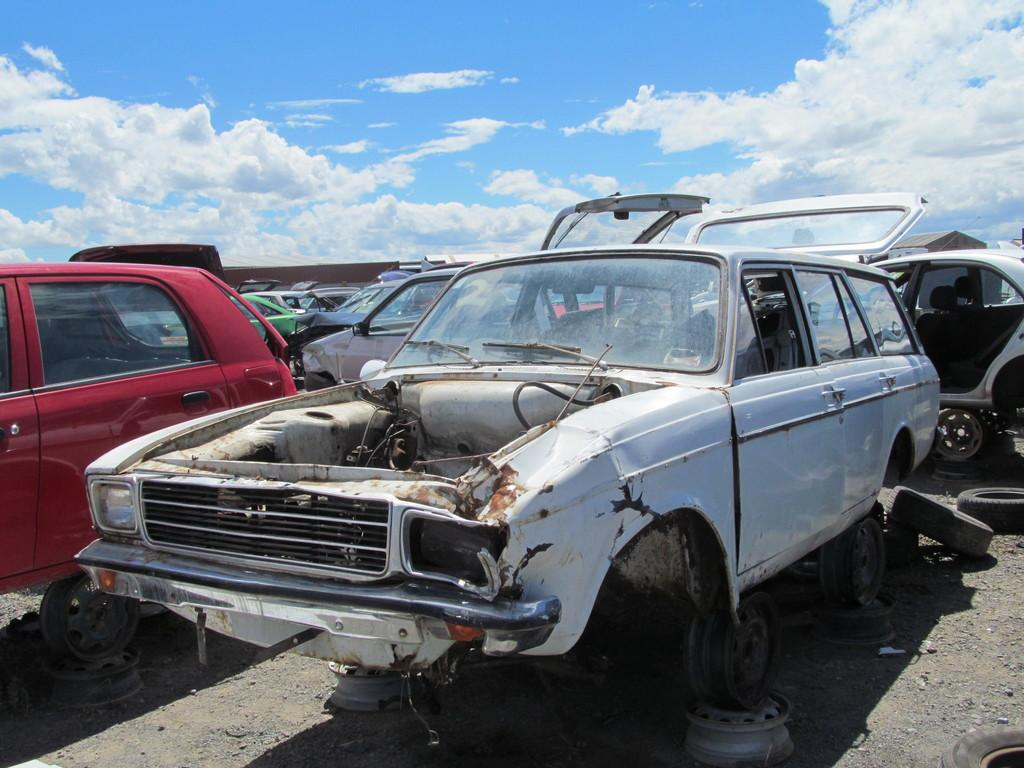What type of vehicles can be seen in the image? There are damaged cars in the image. What tools are present in the image? Wrenches are present in the image. What part of the cars can be seen in the image? Tires are visible in the image. What is visible on the ground in the image? The ground is visible in the image. What can be seen in the sky in the image? There are clouds in the sky in the image. What color is the good-bye wave in the image? There is no good-bye wave present in the image. The image features damaged cars, wrenches, tires, the ground, and clouds in the sky. 